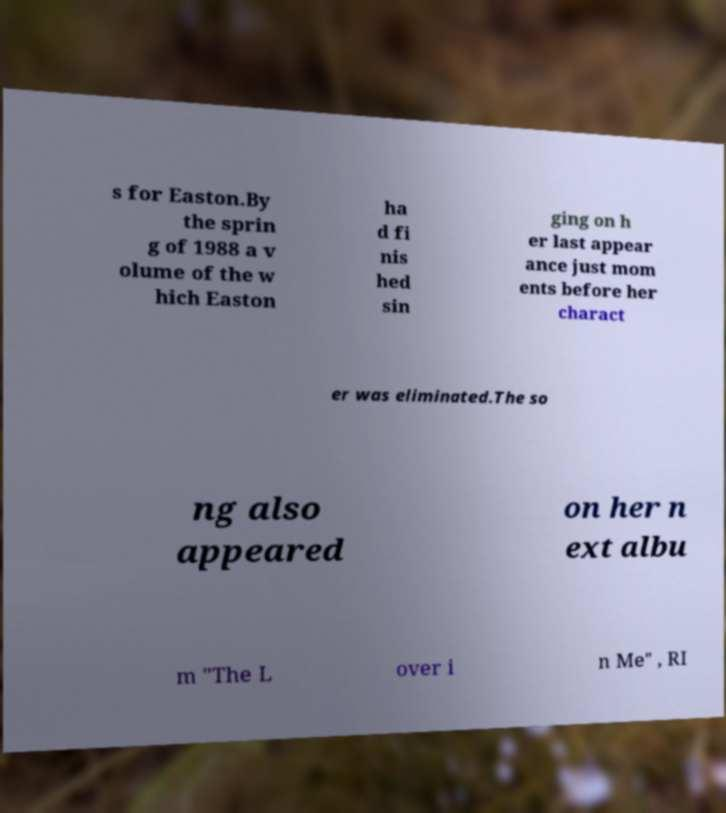Can you accurately transcribe the text from the provided image for me? s for Easton.By the sprin g of 1988 a v olume of the w hich Easton ha d fi nis hed sin ging on h er last appear ance just mom ents before her charact er was eliminated.The so ng also appeared on her n ext albu m "The L over i n Me" , RI 